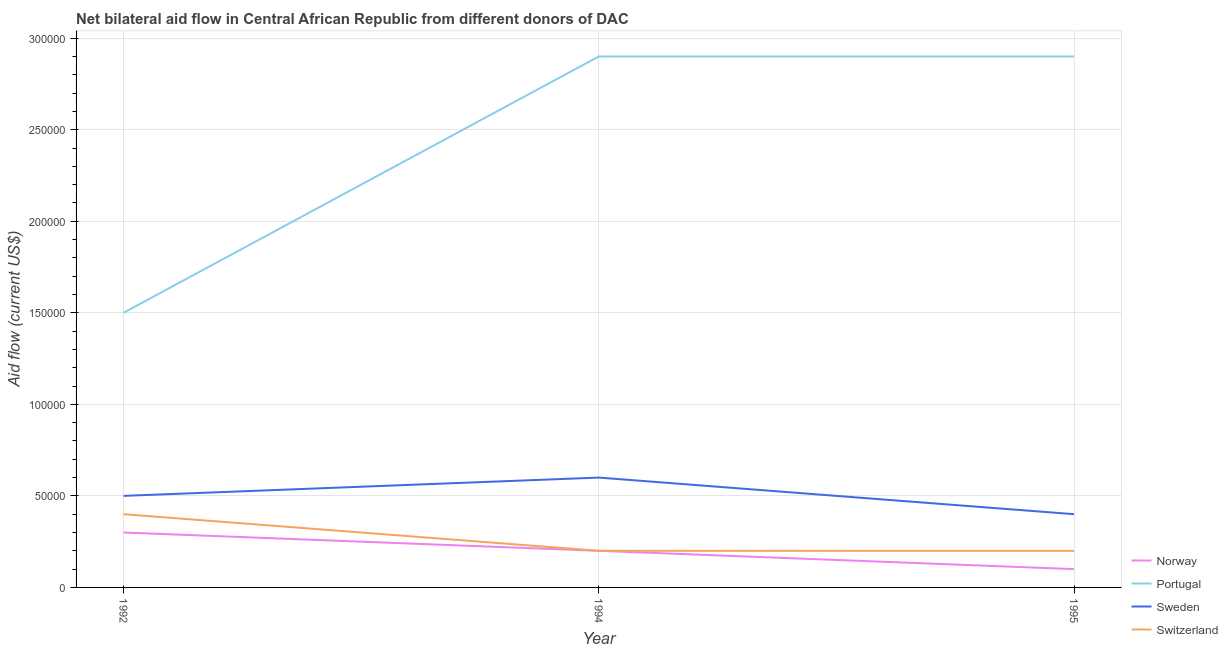Does the line corresponding to amount of aid given by portugal intersect with the line corresponding to amount of aid given by sweden?
Your response must be concise. No. Is the number of lines equal to the number of legend labels?
Offer a very short reply. Yes. What is the amount of aid given by sweden in 1994?
Provide a short and direct response. 6.00e+04. Across all years, what is the maximum amount of aid given by norway?
Keep it short and to the point. 3.00e+04. Across all years, what is the minimum amount of aid given by portugal?
Provide a succinct answer. 1.50e+05. What is the total amount of aid given by switzerland in the graph?
Offer a very short reply. 8.00e+04. What is the difference between the amount of aid given by norway in 1992 and that in 1995?
Make the answer very short. 2.00e+04. What is the difference between the amount of aid given by portugal in 1992 and the amount of aid given by sweden in 1995?
Offer a terse response. 1.10e+05. What is the average amount of aid given by switzerland per year?
Your answer should be very brief. 2.67e+04. In the year 1995, what is the difference between the amount of aid given by portugal and amount of aid given by sweden?
Provide a short and direct response. 2.50e+05. In how many years, is the amount of aid given by portugal greater than 210000 US$?
Ensure brevity in your answer.  2. Is the amount of aid given by switzerland in 1992 less than that in 1995?
Ensure brevity in your answer.  No. Is the difference between the amount of aid given by norway in 1992 and 1994 greater than the difference between the amount of aid given by switzerland in 1992 and 1994?
Give a very brief answer. No. What is the difference between the highest and the second highest amount of aid given by portugal?
Provide a succinct answer. 0. What is the difference between the highest and the lowest amount of aid given by sweden?
Your answer should be very brief. 2.00e+04. In how many years, is the amount of aid given by sweden greater than the average amount of aid given by sweden taken over all years?
Provide a succinct answer. 1. Is it the case that in every year, the sum of the amount of aid given by portugal and amount of aid given by sweden is greater than the sum of amount of aid given by norway and amount of aid given by switzerland?
Your answer should be compact. Yes. Is it the case that in every year, the sum of the amount of aid given by norway and amount of aid given by portugal is greater than the amount of aid given by sweden?
Ensure brevity in your answer.  Yes. Is the amount of aid given by norway strictly greater than the amount of aid given by sweden over the years?
Give a very brief answer. No. Is the amount of aid given by norway strictly less than the amount of aid given by portugal over the years?
Give a very brief answer. Yes. How many lines are there?
Ensure brevity in your answer.  4. What is the difference between two consecutive major ticks on the Y-axis?
Ensure brevity in your answer.  5.00e+04. Are the values on the major ticks of Y-axis written in scientific E-notation?
Offer a very short reply. No. How many legend labels are there?
Provide a succinct answer. 4. How are the legend labels stacked?
Keep it short and to the point. Vertical. What is the title of the graph?
Keep it short and to the point. Net bilateral aid flow in Central African Republic from different donors of DAC. What is the Aid flow (current US$) in Norway in 1992?
Offer a very short reply. 3.00e+04. What is the Aid flow (current US$) of Portugal in 1992?
Offer a terse response. 1.50e+05. What is the Aid flow (current US$) of Sweden in 1992?
Your answer should be compact. 5.00e+04. What is the Aid flow (current US$) in Switzerland in 1992?
Offer a very short reply. 4.00e+04. What is the Aid flow (current US$) of Norway in 1994?
Ensure brevity in your answer.  2.00e+04. What is the Aid flow (current US$) of Portugal in 1994?
Your response must be concise. 2.90e+05. What is the Aid flow (current US$) of Sweden in 1994?
Give a very brief answer. 6.00e+04. Across all years, what is the maximum Aid flow (current US$) in Portugal?
Your answer should be very brief. 2.90e+05. Across all years, what is the maximum Aid flow (current US$) in Sweden?
Your response must be concise. 6.00e+04. Across all years, what is the maximum Aid flow (current US$) in Switzerland?
Make the answer very short. 4.00e+04. Across all years, what is the minimum Aid flow (current US$) in Portugal?
Offer a very short reply. 1.50e+05. Across all years, what is the minimum Aid flow (current US$) in Sweden?
Your answer should be very brief. 4.00e+04. What is the total Aid flow (current US$) in Portugal in the graph?
Offer a terse response. 7.30e+05. What is the total Aid flow (current US$) in Sweden in the graph?
Give a very brief answer. 1.50e+05. What is the total Aid flow (current US$) in Switzerland in the graph?
Offer a terse response. 8.00e+04. What is the difference between the Aid flow (current US$) of Portugal in 1992 and that in 1994?
Offer a terse response. -1.40e+05. What is the difference between the Aid flow (current US$) of Sweden in 1992 and that in 1995?
Keep it short and to the point. 10000. What is the difference between the Aid flow (current US$) in Switzerland in 1992 and that in 1995?
Provide a short and direct response. 2.00e+04. What is the difference between the Aid flow (current US$) in Norway in 1992 and the Aid flow (current US$) in Sweden in 1994?
Offer a very short reply. -3.00e+04. What is the difference between the Aid flow (current US$) of Norway in 1992 and the Aid flow (current US$) of Switzerland in 1994?
Offer a terse response. 10000. What is the difference between the Aid flow (current US$) of Sweden in 1992 and the Aid flow (current US$) of Switzerland in 1994?
Give a very brief answer. 3.00e+04. What is the difference between the Aid flow (current US$) of Norway in 1992 and the Aid flow (current US$) of Portugal in 1995?
Provide a succinct answer. -2.60e+05. What is the difference between the Aid flow (current US$) of Norway in 1992 and the Aid flow (current US$) of Switzerland in 1995?
Provide a short and direct response. 10000. What is the difference between the Aid flow (current US$) in Portugal in 1992 and the Aid flow (current US$) in Sweden in 1995?
Make the answer very short. 1.10e+05. What is the difference between the Aid flow (current US$) in Portugal in 1992 and the Aid flow (current US$) in Switzerland in 1995?
Provide a succinct answer. 1.30e+05. What is the difference between the Aid flow (current US$) in Norway in 1994 and the Aid flow (current US$) in Portugal in 1995?
Keep it short and to the point. -2.70e+05. What is the difference between the Aid flow (current US$) in Portugal in 1994 and the Aid flow (current US$) in Sweden in 1995?
Offer a terse response. 2.50e+05. What is the average Aid flow (current US$) in Portugal per year?
Keep it short and to the point. 2.43e+05. What is the average Aid flow (current US$) of Switzerland per year?
Offer a terse response. 2.67e+04. In the year 1992, what is the difference between the Aid flow (current US$) of Norway and Aid flow (current US$) of Portugal?
Give a very brief answer. -1.20e+05. In the year 1992, what is the difference between the Aid flow (current US$) of Norway and Aid flow (current US$) of Sweden?
Your answer should be very brief. -2.00e+04. In the year 1992, what is the difference between the Aid flow (current US$) of Norway and Aid flow (current US$) of Switzerland?
Provide a succinct answer. -10000. In the year 1994, what is the difference between the Aid flow (current US$) in Norway and Aid flow (current US$) in Sweden?
Your answer should be compact. -4.00e+04. In the year 1994, what is the difference between the Aid flow (current US$) in Norway and Aid flow (current US$) in Switzerland?
Offer a very short reply. 0. In the year 1994, what is the difference between the Aid flow (current US$) in Portugal and Aid flow (current US$) in Sweden?
Ensure brevity in your answer.  2.30e+05. In the year 1994, what is the difference between the Aid flow (current US$) of Sweden and Aid flow (current US$) of Switzerland?
Make the answer very short. 4.00e+04. In the year 1995, what is the difference between the Aid flow (current US$) in Norway and Aid flow (current US$) in Portugal?
Ensure brevity in your answer.  -2.80e+05. In the year 1995, what is the difference between the Aid flow (current US$) of Norway and Aid flow (current US$) of Sweden?
Your answer should be compact. -3.00e+04. In the year 1995, what is the difference between the Aid flow (current US$) in Norway and Aid flow (current US$) in Switzerland?
Your answer should be compact. -10000. In the year 1995, what is the difference between the Aid flow (current US$) in Portugal and Aid flow (current US$) in Sweden?
Make the answer very short. 2.50e+05. In the year 1995, what is the difference between the Aid flow (current US$) in Sweden and Aid flow (current US$) in Switzerland?
Your response must be concise. 2.00e+04. What is the ratio of the Aid flow (current US$) of Portugal in 1992 to that in 1994?
Give a very brief answer. 0.52. What is the ratio of the Aid flow (current US$) of Sweden in 1992 to that in 1994?
Provide a succinct answer. 0.83. What is the ratio of the Aid flow (current US$) of Portugal in 1992 to that in 1995?
Provide a succinct answer. 0.52. What is the difference between the highest and the second highest Aid flow (current US$) in Portugal?
Offer a terse response. 0. What is the difference between the highest and the second highest Aid flow (current US$) in Switzerland?
Offer a terse response. 2.00e+04. What is the difference between the highest and the lowest Aid flow (current US$) in Switzerland?
Give a very brief answer. 2.00e+04. 